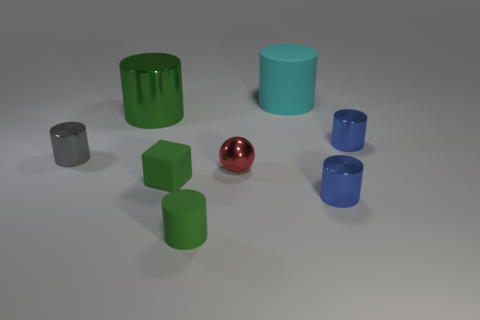Subtract 1 cylinders. How many cylinders are left? 5 Subtract all blue cylinders. How many cylinders are left? 4 Subtract all tiny matte cylinders. How many cylinders are left? 5 Subtract all red cylinders. Subtract all blue blocks. How many cylinders are left? 6 Add 1 green shiny objects. How many objects exist? 9 Subtract all cubes. How many objects are left? 7 Add 3 big green metallic cylinders. How many big green metallic cylinders are left? 4 Add 7 green shiny objects. How many green shiny objects exist? 8 Subtract 0 yellow cubes. How many objects are left? 8 Subtract all small rubber things. Subtract all big cyan cylinders. How many objects are left? 5 